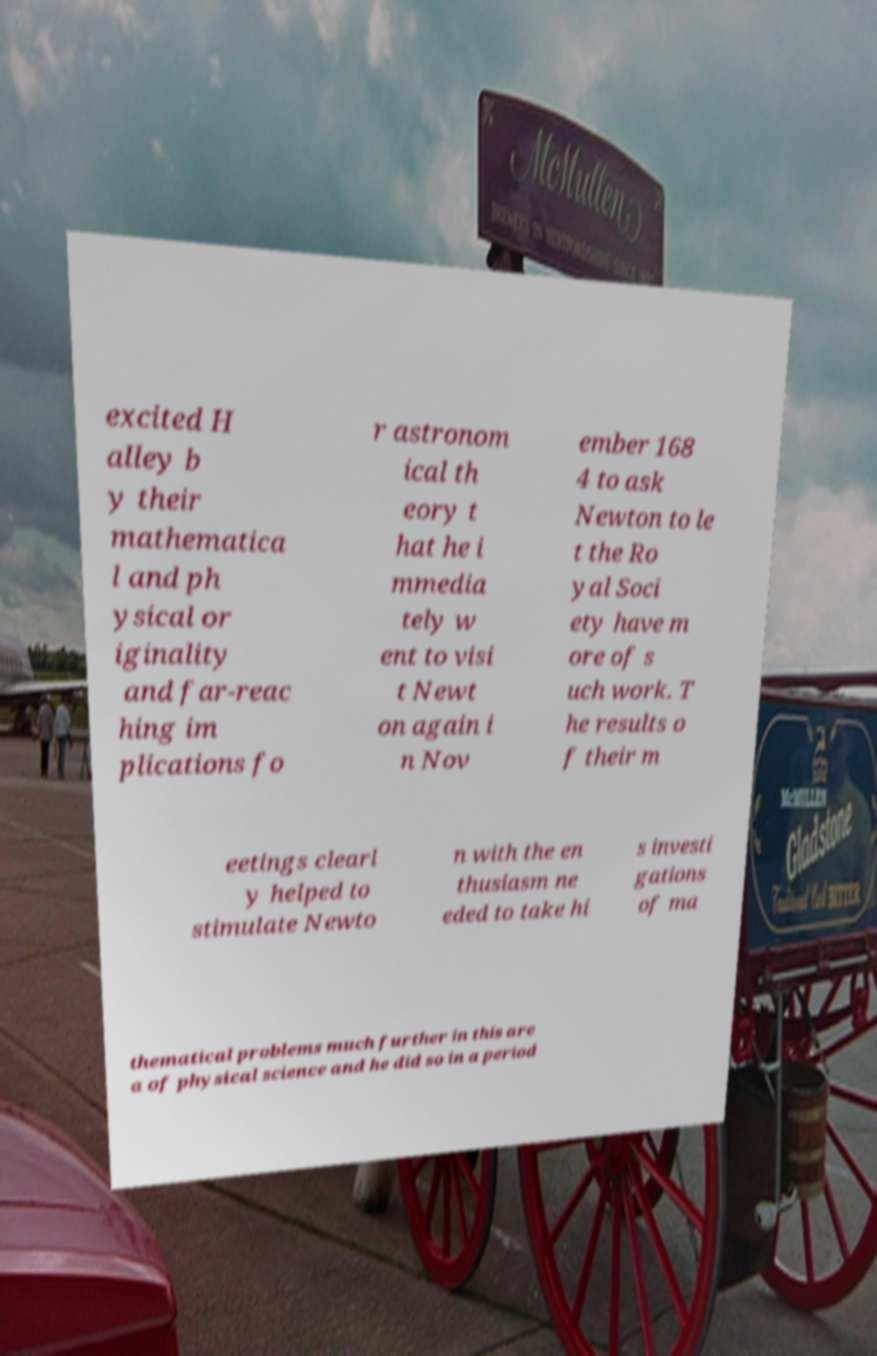For documentation purposes, I need the text within this image transcribed. Could you provide that? excited H alley b y their mathematica l and ph ysical or iginality and far-reac hing im plications fo r astronom ical th eory t hat he i mmedia tely w ent to visi t Newt on again i n Nov ember 168 4 to ask Newton to le t the Ro yal Soci ety have m ore of s uch work. T he results o f their m eetings clearl y helped to stimulate Newto n with the en thusiasm ne eded to take hi s investi gations of ma thematical problems much further in this are a of physical science and he did so in a period 